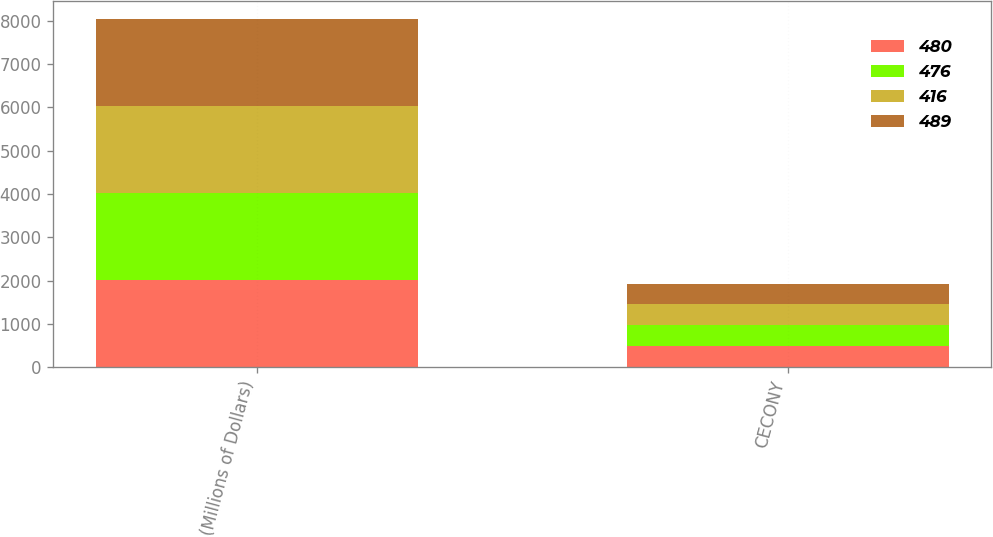<chart> <loc_0><loc_0><loc_500><loc_500><stacked_bar_chart><ecel><fcel>(Millions of Dollars)<fcel>CECONY<nl><fcel>480<fcel>2010<fcel>489<nl><fcel>476<fcel>2011<fcel>480<nl><fcel>416<fcel>2012<fcel>479<nl><fcel>489<fcel>2013<fcel>476<nl></chart> 